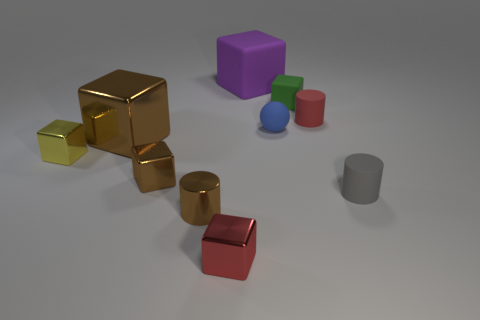There is a small object left of the big brown block to the left of the small thing that is to the right of the small red rubber thing; what is its material?
Give a very brief answer. Metal. What number of other objects are the same shape as the large purple object?
Make the answer very short. 5. What color is the matte thing that is in front of the yellow shiny block?
Your answer should be very brief. Gray. There is a tiny red object in front of the tiny red thing on the right side of the small red block; what number of tiny gray matte cylinders are to the left of it?
Offer a terse response. 0. How many gray things are to the right of the cube on the right side of the small blue matte sphere?
Your response must be concise. 1. How many small green blocks are in front of the small ball?
Your answer should be compact. 0. How many other objects are the same size as the purple thing?
Ensure brevity in your answer.  1. There is a metallic object that is the same shape as the small gray matte object; what size is it?
Provide a short and direct response. Small. What is the shape of the small red object behind the yellow cube?
Offer a terse response. Cylinder. What color is the rubber block in front of the big object behind the small green rubber thing?
Ensure brevity in your answer.  Green. 